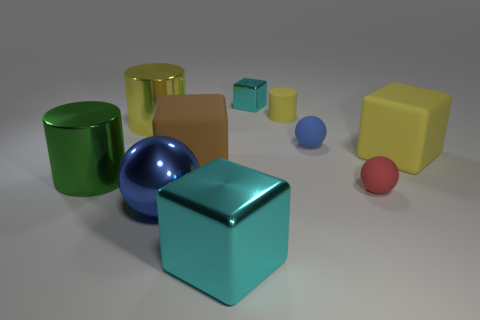If these objects were part of a children's game, what could be some potential rules? If these objects were part of a children's game, one potential rule could be to sort them by color or shape. Another rule could be to stack the objects without toppling them over, or to use them in a memory game where players match similar objects hidden under cups. The variety of shapes and colors lend themselves to creative play and learning activities. 